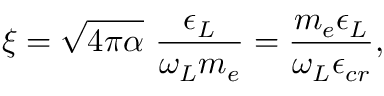<formula> <loc_0><loc_0><loc_500><loc_500>\xi = \sqrt { 4 \pi \alpha } \, \frac { \epsilon _ { L } } { \omega _ { L } m _ { e } } = \frac { m _ { e } \epsilon _ { L } } { \omega _ { L } \epsilon _ { c r } } ,</formula> 